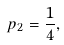<formula> <loc_0><loc_0><loc_500><loc_500>p _ { 2 } = \frac { 1 } { 4 } ,</formula> 